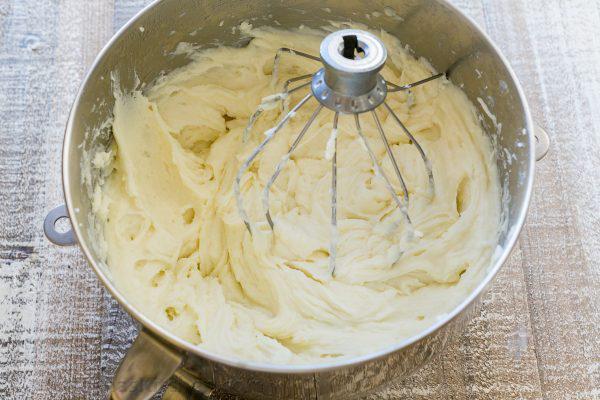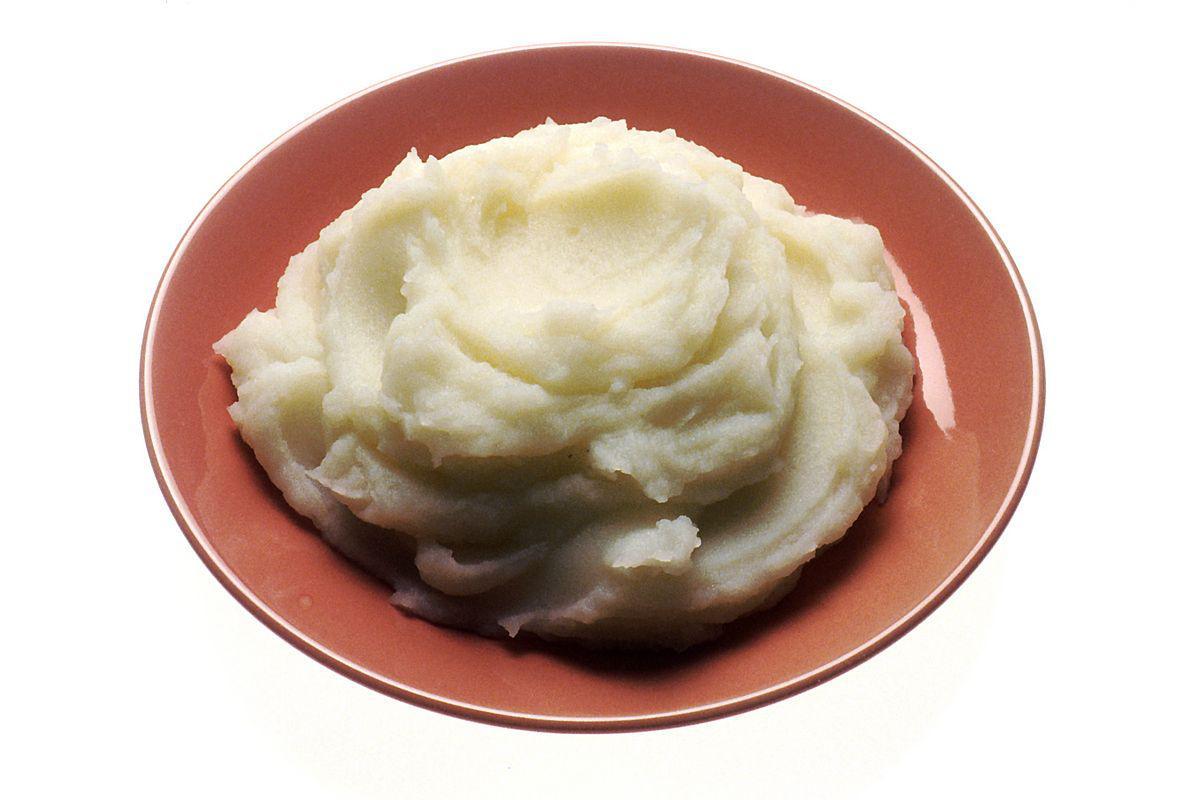The first image is the image on the left, the second image is the image on the right. Considering the images on both sides, is "Oily butter is melting on at least one of the dishes." valid? Answer yes or no. No. 